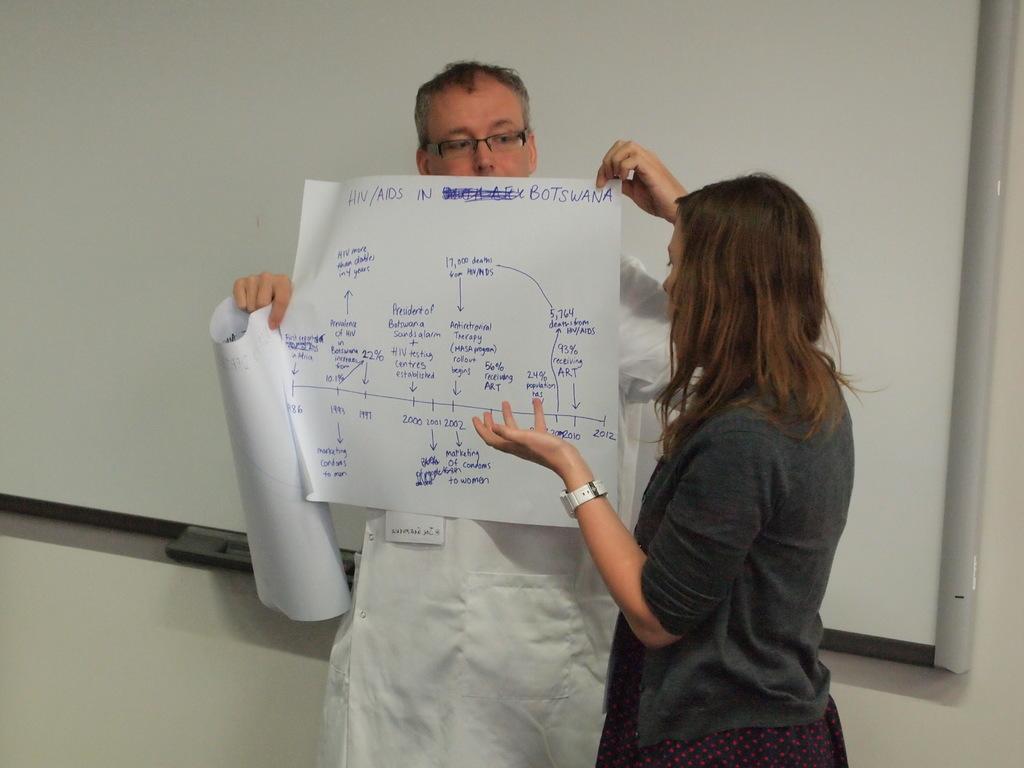Please provide a concise description of this image. In this image a person wearing a white top is holding papers in his hand. He is wearing spectacles. Beside him there is a woman standing. Background there is a board attached to the wall. 